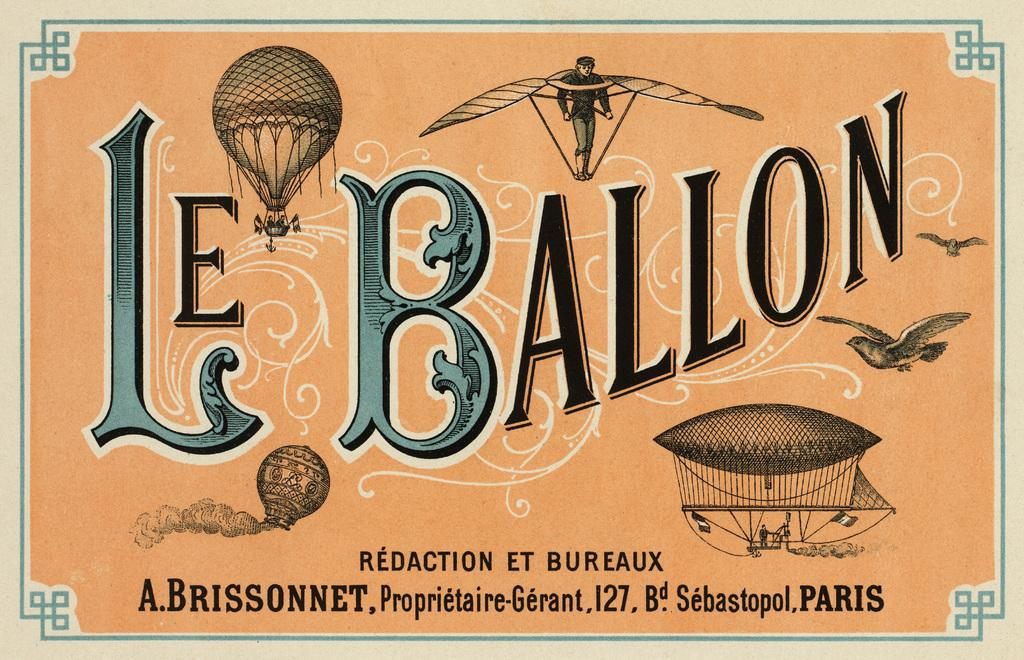<image>
Share a concise interpretation of the image provided. A french advertisment for hot air balloons displayed the words "Le Ballon" on the front. 